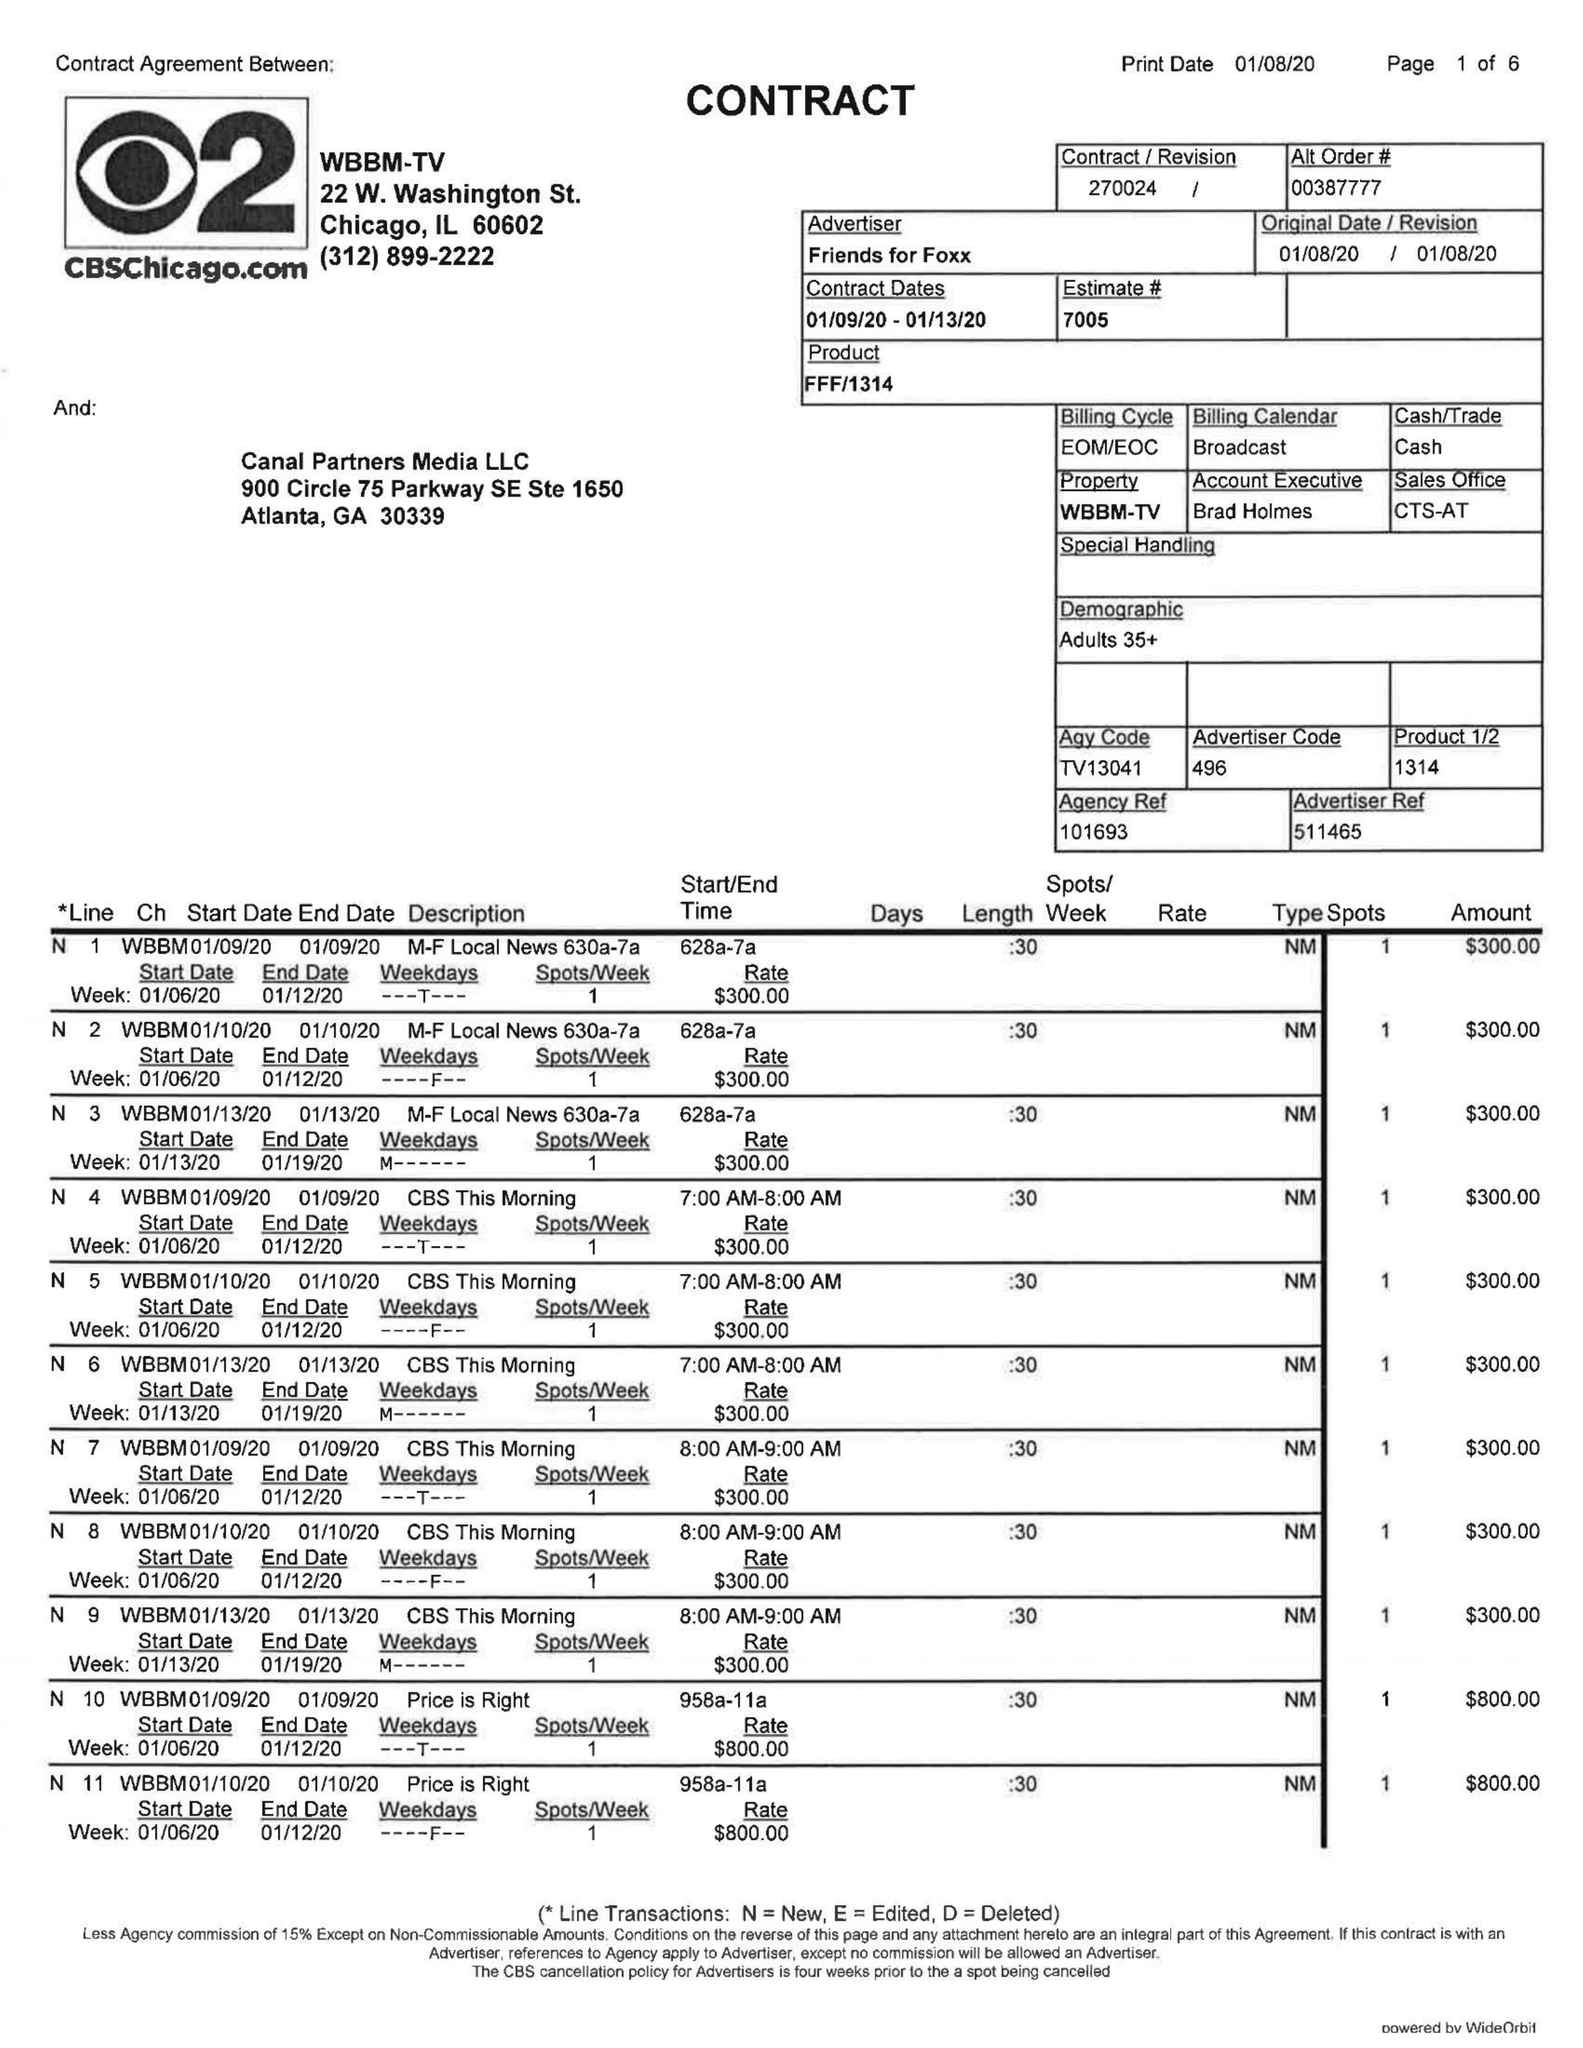What is the value for the contract_num?
Answer the question using a single word or phrase. 270024 